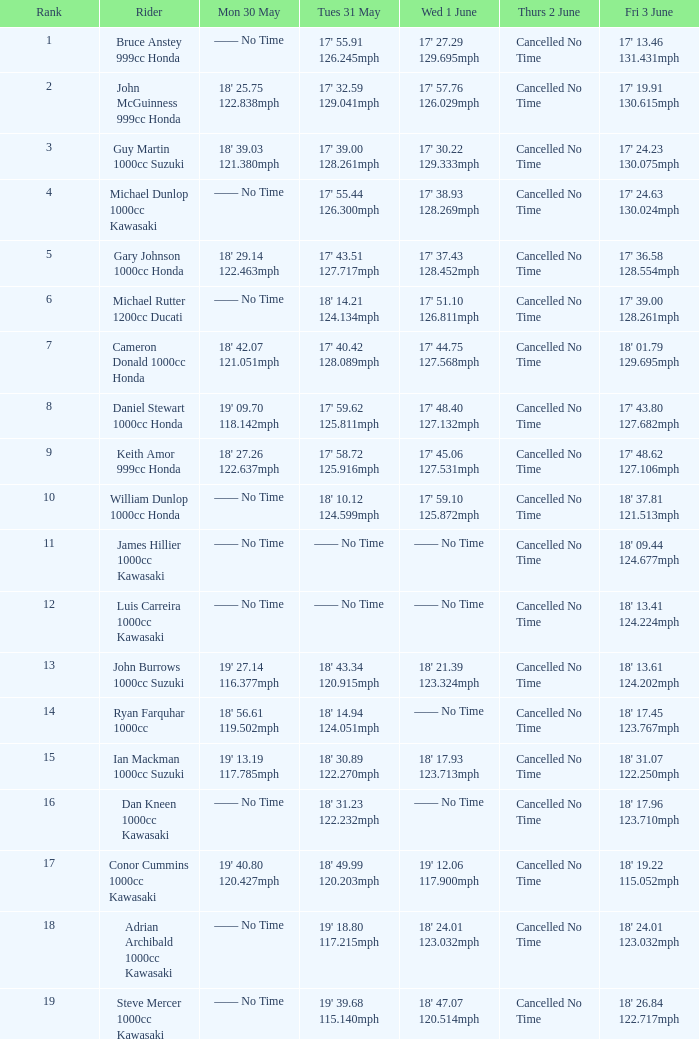What is the Fri 3 June time for the rider whose Tues 31 May time was 19' 18.80 117.215mph? 18' 24.01 123.032mph. 